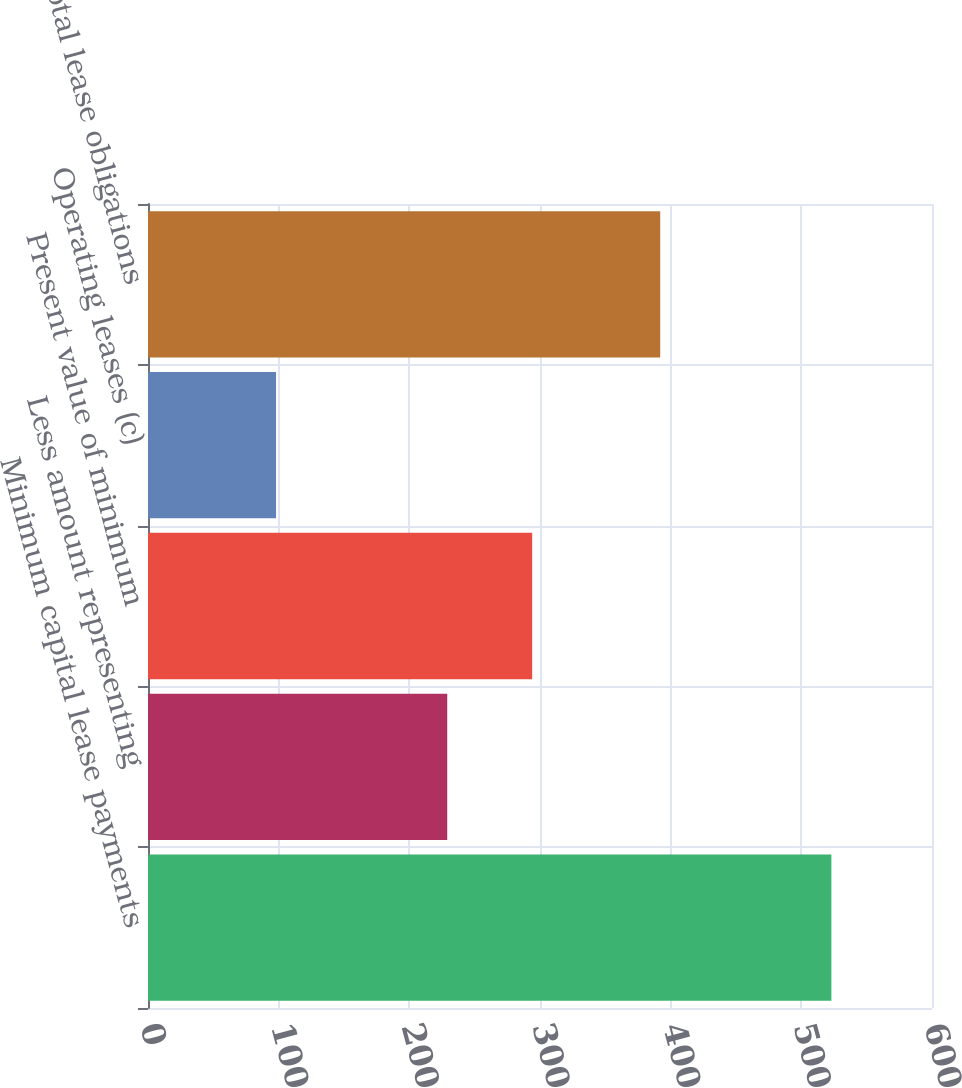Convert chart to OTSL. <chart><loc_0><loc_0><loc_500><loc_500><bar_chart><fcel>Minimum capital lease payments<fcel>Less amount representing<fcel>Present value of minimum<fcel>Operating leases (c)<fcel>Total lease obligations<nl><fcel>523<fcel>229<fcel>294<fcel>98<fcel>392<nl></chart> 